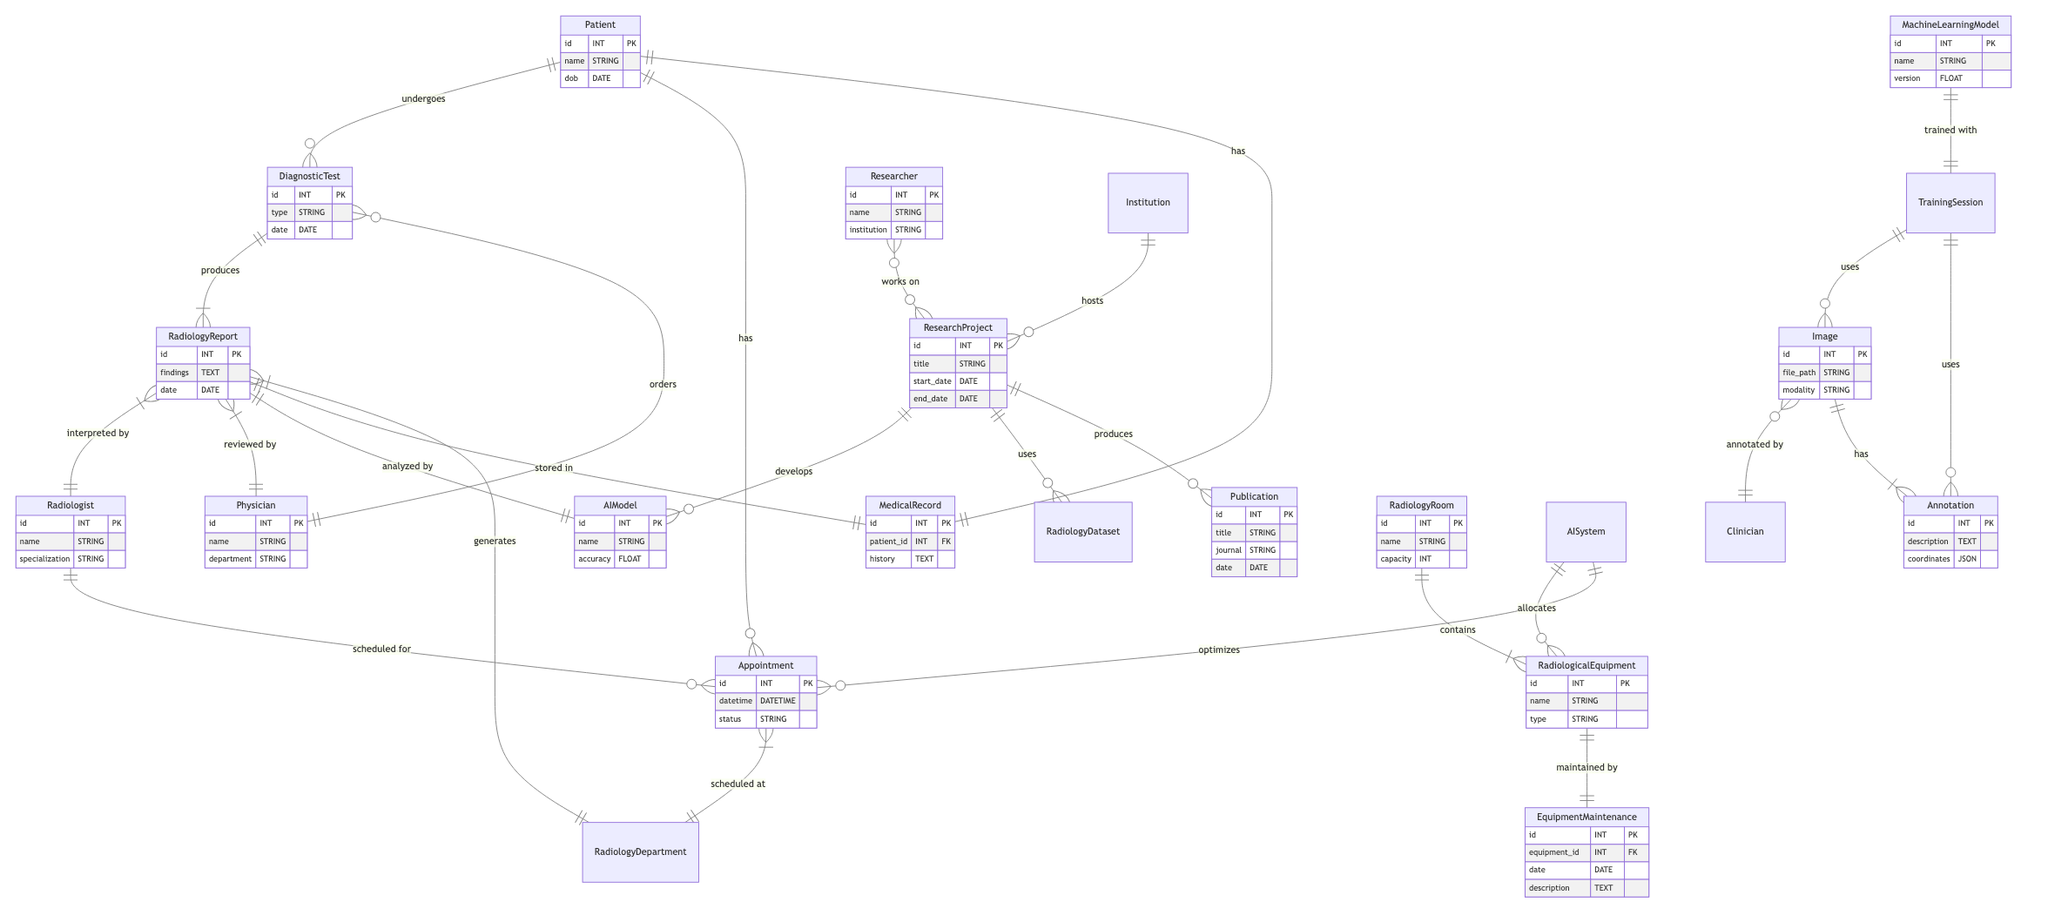What are the entities in the Patient Diagnostic Data Management ER diagram? The entities can be found in the upper section of the diagram, listing Patient, Diagnostic Test, Radiology Report, Radiologist, and Physician.
Answer: Patient, Diagnostic Test, Radiology Report, Radiologist, Physician How many relationships are depicted in the Machine Learning Algorithm Training Dataset diagram? By counting the lines connecting the entities, we find a total of 4 relationships shown in this specific part of the diagram.
Answer: 4 Which entity is associated with the appointment in the Hospital Information System with AI-Enhanced Radiology Workflow diagram? The line connecting Patient to Appointment indicates that the Patient is the entity associated with the appointment.
Answer: Patient What does the Radiology Report produce in the Patient Diagnostic Data Management diagram? The relationship line between Diagnostic Test and Radiology Report indicates that the Radiology Report is produced by the Diagnostic Test as per the labeling on the connecting line.
Answer: Radiology Report Who analyzes the Radiology Report in the Hospital Information System with AI-Enhanced Radiology Workflow? The diagram states that the Radiology Report is analyzed by the AI Model, seen in the relationship connecting these two entities.
Answer: AI Model Where does the Research Project utilize the AI Model in the Research Collaboration on AI in Radiology diagram? The relationship shown between Research Project and AI Model indicates that the Research Project utilizes the AI Model as part of its process.
Answer: AI Model How are Radiological Equipment maintained according to the Radiology Department Resource Allocation diagram? The relationship shows that the Equipment Maintenance is responsible for maintaining the Radiological Equipment, which is indicated by the connection between these two entities.
Answer: Equipment Maintenance What is required for training the Machine Learning Model based on the training sessions represented in the diagram? The relationship indicates that the Machine Learning Model is trained with data from the Training Session, requiring images and annotations represented in the connections.
Answer: Training Session Which role orders a Diagnostic Test in the Patient Diagnostic Data Management diagram? The diagram indicates that the Physician orders a Diagnostic Test, as shown by the relationship arrow from Physician to Diagnostic Test.
Answer: Physician What is the relationship between Radiology Room and Radiological Equipment? The diagram indicates that the Radiology Room contains the Radiological Equipment, as depicted by the directional relationship connecting these two entities.
Answer: contains 